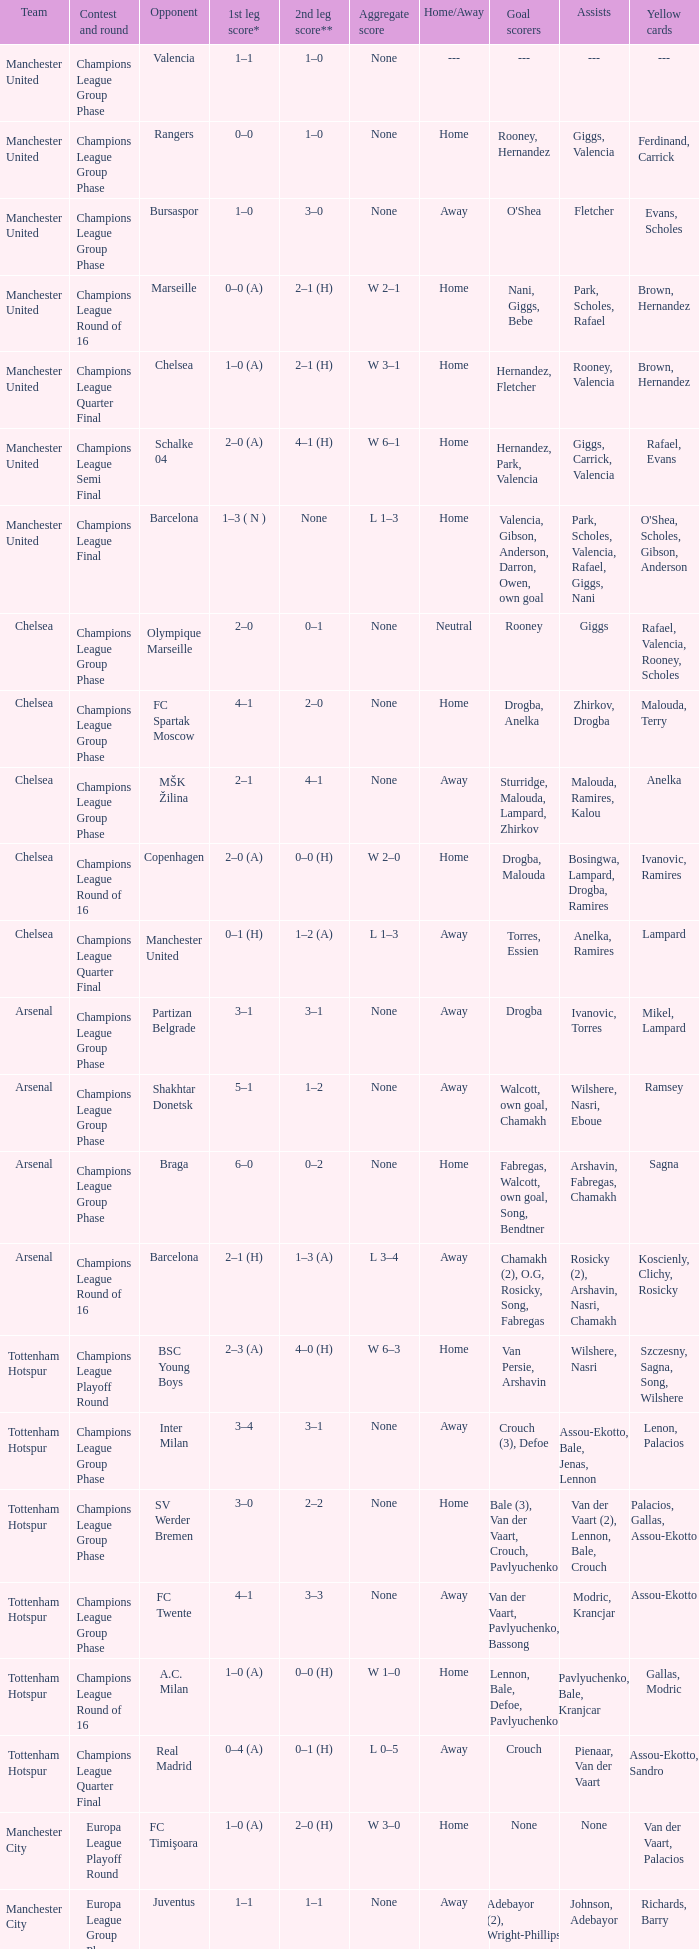How many goals did each team score in the first leg of the match between Liverpool and Steaua Bucureşti? 4–1. 